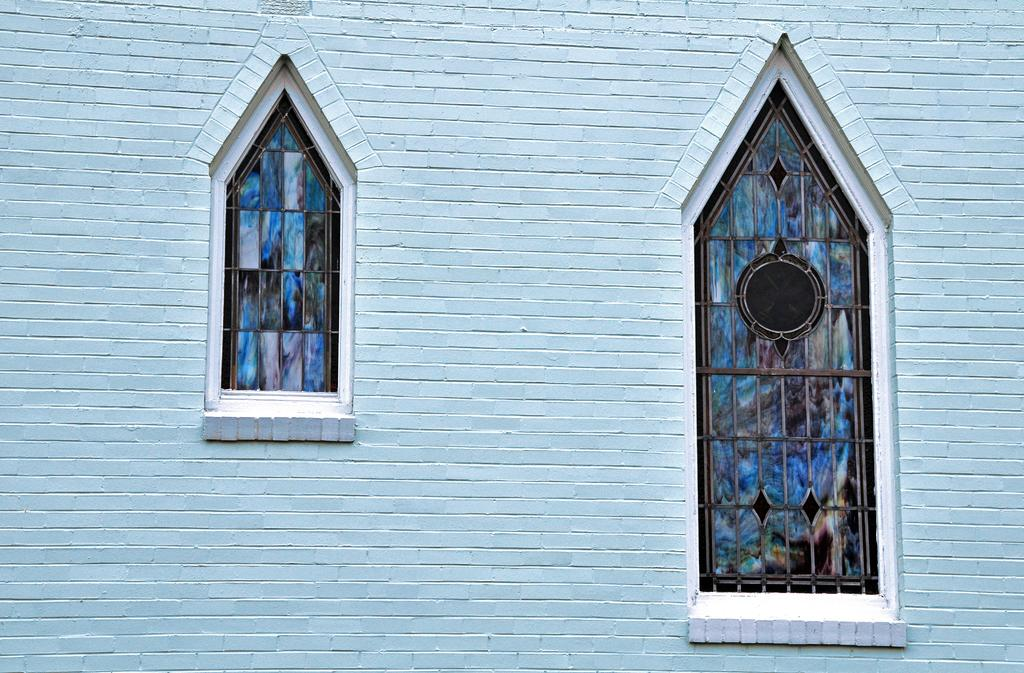What is present on the wall in the image? There is a wall in the image, and two glass windows are on the wall. How many windows are visible on the wall? There are two glass windows on the wall. What type of wire is used to hold the pizzas on the wall in the image? There are no pizzas or wires present in the image; it only features a wall with two glass windows. 